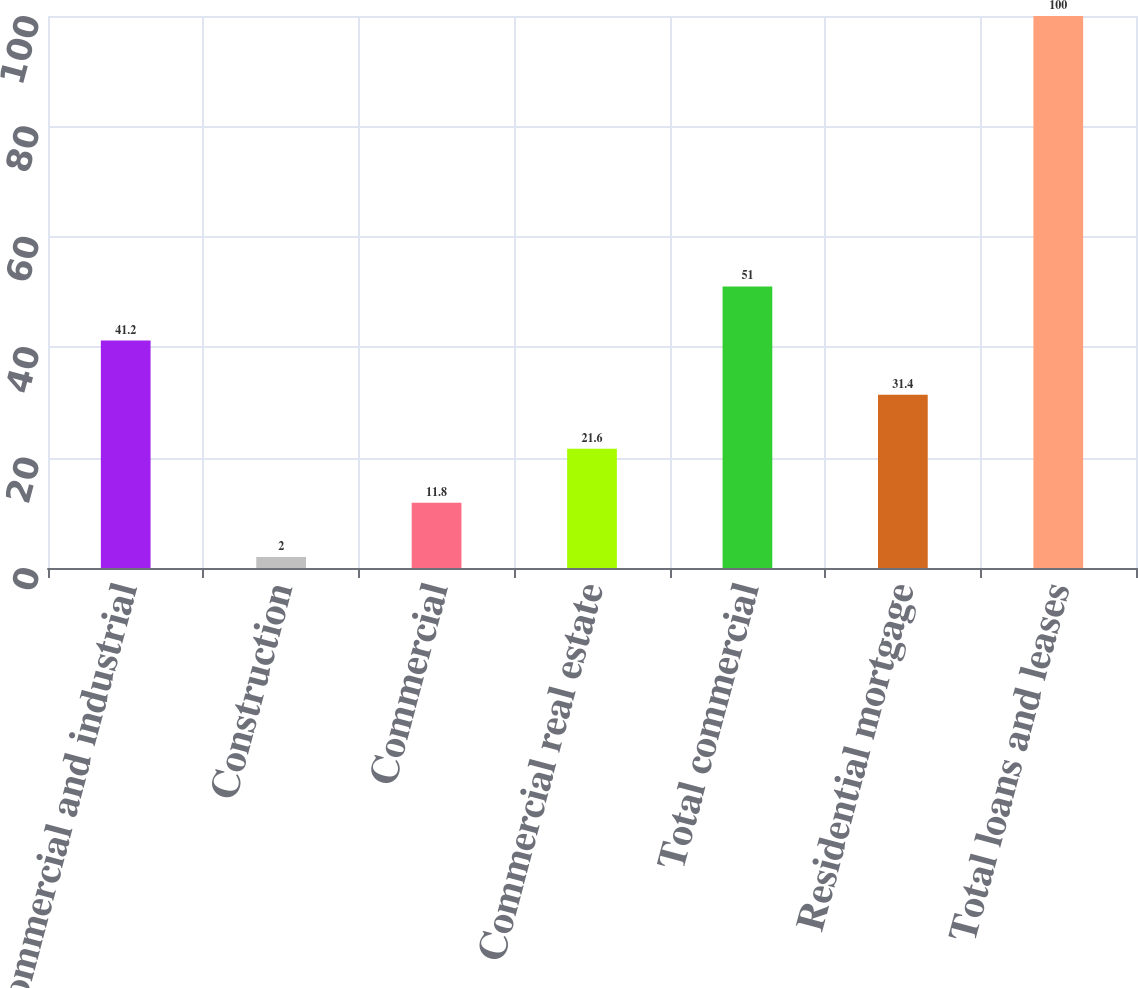Convert chart. <chart><loc_0><loc_0><loc_500><loc_500><bar_chart><fcel>Commercial and industrial<fcel>Construction<fcel>Commercial<fcel>Commercial real estate<fcel>Total commercial<fcel>Residential mortgage<fcel>Total loans and leases<nl><fcel>41.2<fcel>2<fcel>11.8<fcel>21.6<fcel>51<fcel>31.4<fcel>100<nl></chart> 